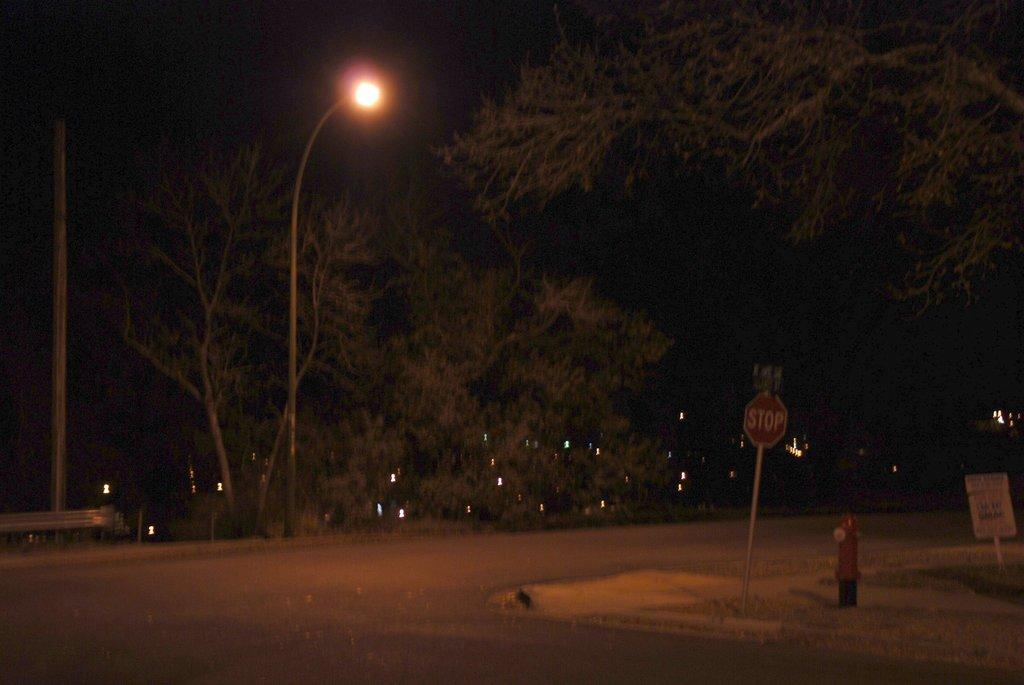What is the main feature of the image? There is a road in the image. Are there any signs or markers along the road? Yes, there is a sign board in the image. Are there any objects related to water or fire safety in the image? Yes, there is a hydrant in the image. Are there any vertical structures along the road? Yes, there is a street pole in the image. Is there any source of illumination in the image? Yes, there is a street light in the image. What type of natural elements can be seen in the image? There are trees in the image. Are there any additional sources of light in the image? Yes, there are electric lights in the image. Can you tell me how many potatoes are hidden behind the street light in the image? There are no potatoes present in the image, so it is not possible to determine how many there might be. 